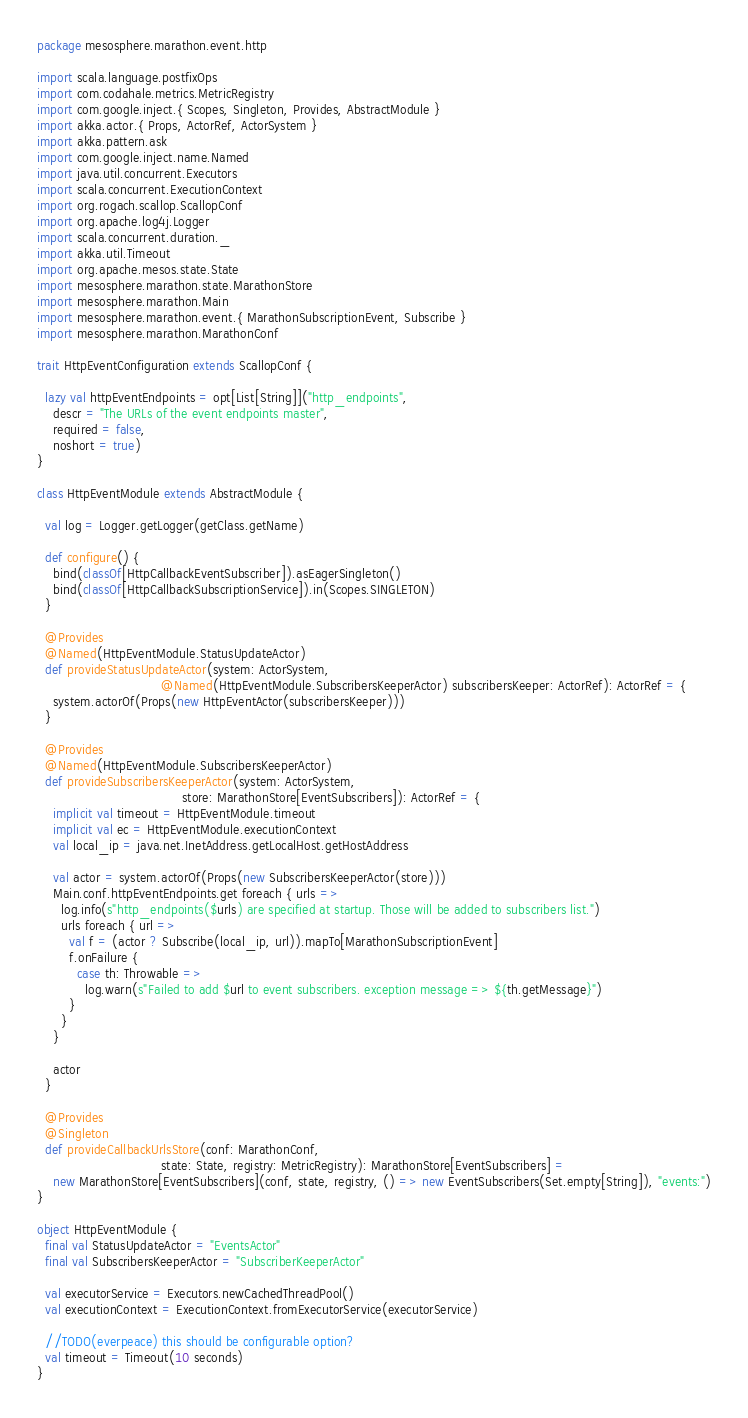Convert code to text. <code><loc_0><loc_0><loc_500><loc_500><_Scala_>package mesosphere.marathon.event.http

import scala.language.postfixOps
import com.codahale.metrics.MetricRegistry
import com.google.inject.{ Scopes, Singleton, Provides, AbstractModule }
import akka.actor.{ Props, ActorRef, ActorSystem }
import akka.pattern.ask
import com.google.inject.name.Named
import java.util.concurrent.Executors
import scala.concurrent.ExecutionContext
import org.rogach.scallop.ScallopConf
import org.apache.log4j.Logger
import scala.concurrent.duration._
import akka.util.Timeout
import org.apache.mesos.state.State
import mesosphere.marathon.state.MarathonStore
import mesosphere.marathon.Main
import mesosphere.marathon.event.{ MarathonSubscriptionEvent, Subscribe }
import mesosphere.marathon.MarathonConf

trait HttpEventConfiguration extends ScallopConf {

  lazy val httpEventEndpoints = opt[List[String]]("http_endpoints",
    descr = "The URLs of the event endpoints master",
    required = false,
    noshort = true)
}

class HttpEventModule extends AbstractModule {

  val log = Logger.getLogger(getClass.getName)

  def configure() {
    bind(classOf[HttpCallbackEventSubscriber]).asEagerSingleton()
    bind(classOf[HttpCallbackSubscriptionService]).in(Scopes.SINGLETON)
  }

  @Provides
  @Named(HttpEventModule.StatusUpdateActor)
  def provideStatusUpdateActor(system: ActorSystem,
                               @Named(HttpEventModule.SubscribersKeeperActor) subscribersKeeper: ActorRef): ActorRef = {
    system.actorOf(Props(new HttpEventActor(subscribersKeeper)))
  }

  @Provides
  @Named(HttpEventModule.SubscribersKeeperActor)
  def provideSubscribersKeeperActor(system: ActorSystem,
                                    store: MarathonStore[EventSubscribers]): ActorRef = {
    implicit val timeout = HttpEventModule.timeout
    implicit val ec = HttpEventModule.executionContext
    val local_ip = java.net.InetAddress.getLocalHost.getHostAddress

    val actor = system.actorOf(Props(new SubscribersKeeperActor(store)))
    Main.conf.httpEventEndpoints.get foreach { urls =>
      log.info(s"http_endpoints($urls) are specified at startup. Those will be added to subscribers list.")
      urls foreach { url =>
        val f = (actor ? Subscribe(local_ip, url)).mapTo[MarathonSubscriptionEvent]
        f.onFailure {
          case th: Throwable =>
            log.warn(s"Failed to add $url to event subscribers. exception message => ${th.getMessage}")
        }
      }
    }

    actor
  }

  @Provides
  @Singleton
  def provideCallbackUrlsStore(conf: MarathonConf,
                               state: State, registry: MetricRegistry): MarathonStore[EventSubscribers] =
    new MarathonStore[EventSubscribers](conf, state, registry, () => new EventSubscribers(Set.empty[String]), "events:")
}

object HttpEventModule {
  final val StatusUpdateActor = "EventsActor"
  final val SubscribersKeeperActor = "SubscriberKeeperActor"

  val executorService = Executors.newCachedThreadPool()
  val executionContext = ExecutionContext.fromExecutorService(executorService)

  //TODO(everpeace) this should be configurable option?
  val timeout = Timeout(10 seconds)
}

</code> 